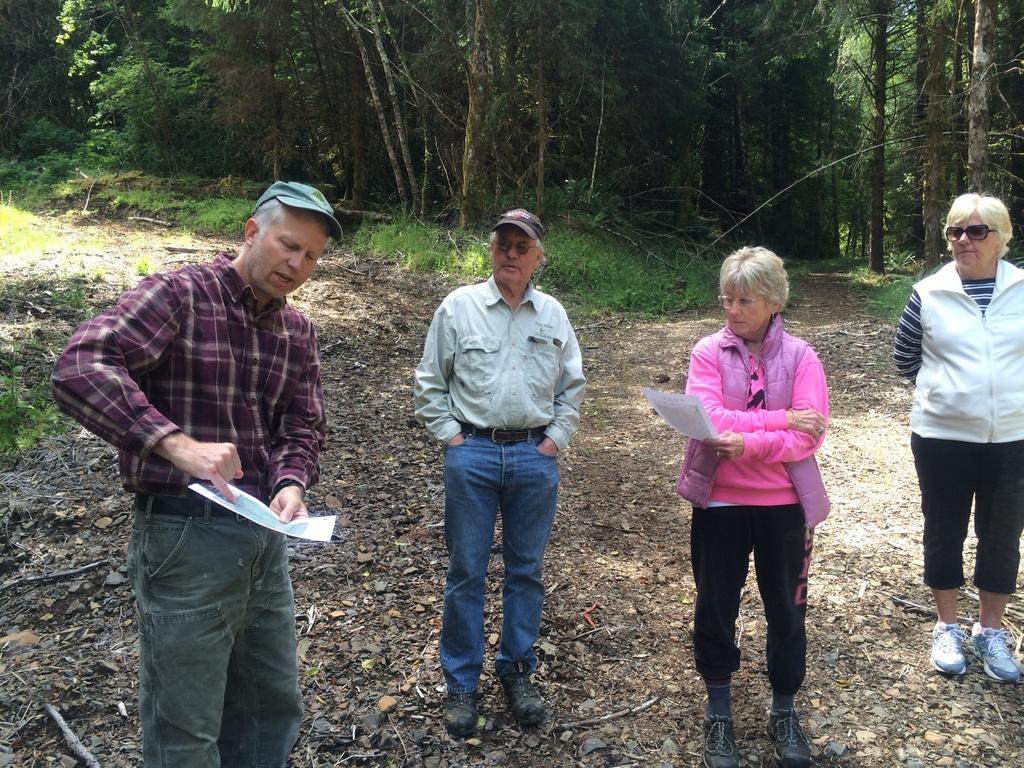How would you summarize this image in a sentence or two? In this image we can see few people standing and there are two persons holding paper in their hand and we can see some trees and grass on the ground. 